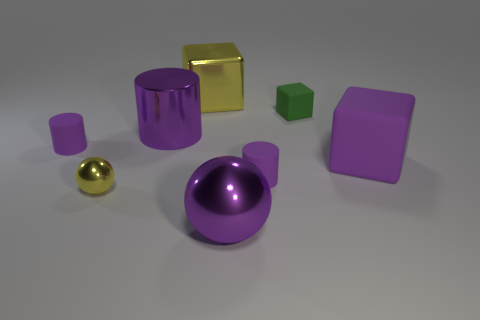Are there an equal number of big metal cubes on the right side of the big purple cube and big cyan matte objects?
Offer a terse response. Yes. What size is the purple matte cube?
Provide a succinct answer. Large. There is a purple rubber object that is to the right of the small green thing; what number of purple rubber things are in front of it?
Your response must be concise. 1. What shape is the small object that is to the right of the yellow cube and in front of the large purple rubber object?
Ensure brevity in your answer.  Cylinder. What number of large metal spheres are the same color as the large cylinder?
Offer a very short reply. 1. Is there a small matte thing that is left of the metallic thing that is right of the big cube behind the green rubber object?
Your answer should be very brief. Yes. What size is the purple thing that is both in front of the large rubber cube and behind the tiny yellow thing?
Your answer should be very brief. Small. How many other big cubes are the same material as the big yellow block?
Offer a very short reply. 0. How many cylinders are tiny yellow shiny things or purple metal objects?
Your response must be concise. 1. How big is the ball on the right side of the large block on the left side of the large cube that is in front of the green object?
Provide a short and direct response. Large. 